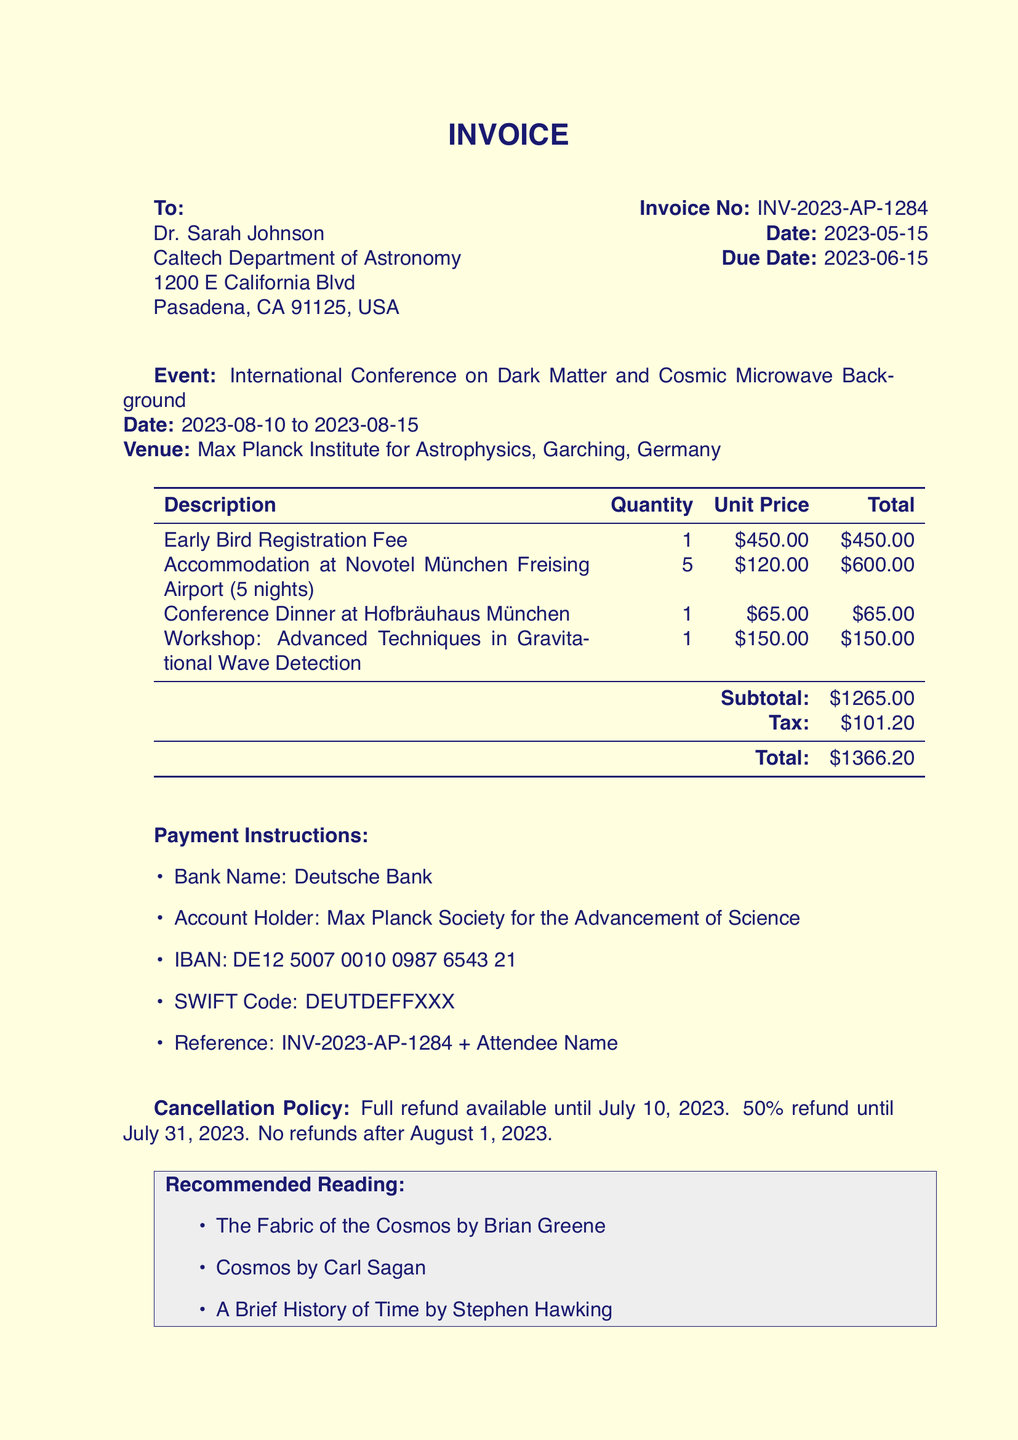What is the invoice number? The invoice number is given at the top of the document for identification purposes.
Answer: INV-2023-AP-1284 Who is the recipient of the invoice? The recipient's name and institution are mentioned in the "To" section of the invoice.
Answer: Dr. Sarah Johnson What is the total amount due? The total amount due is specified in the document, summing up all charges including tax.
Answer: 1366.20 What is the due date for payment? The due date is indicated clearly in the invoice for payment submission.
Answer: 2023-06-15 How many nights is the accommodation for? The number of nights for accommodation is part of the description of the accommodation item.
Answer: 5 nights What is the cancellation policy after August 1, 2023? The cancellation policy describes the consequences of canceling after a specific date and is stated in the additional information.
Answer: No refunds after August 1, 2023 What is the venue for the conference? The venue is outlined in the event details section of the invoice.
Answer: Max Planck Institute for Astrophysics, Garching, Germany Who is the keynote speaker at the conference? The highlights section mentions the keynote speaker's name and subject of the talk.
Answer: Dr. Kip Thorne What payment method is accepted? The payment instructions section provides the necessary banking details for processing the payment.
Answer: Bank Transfer 